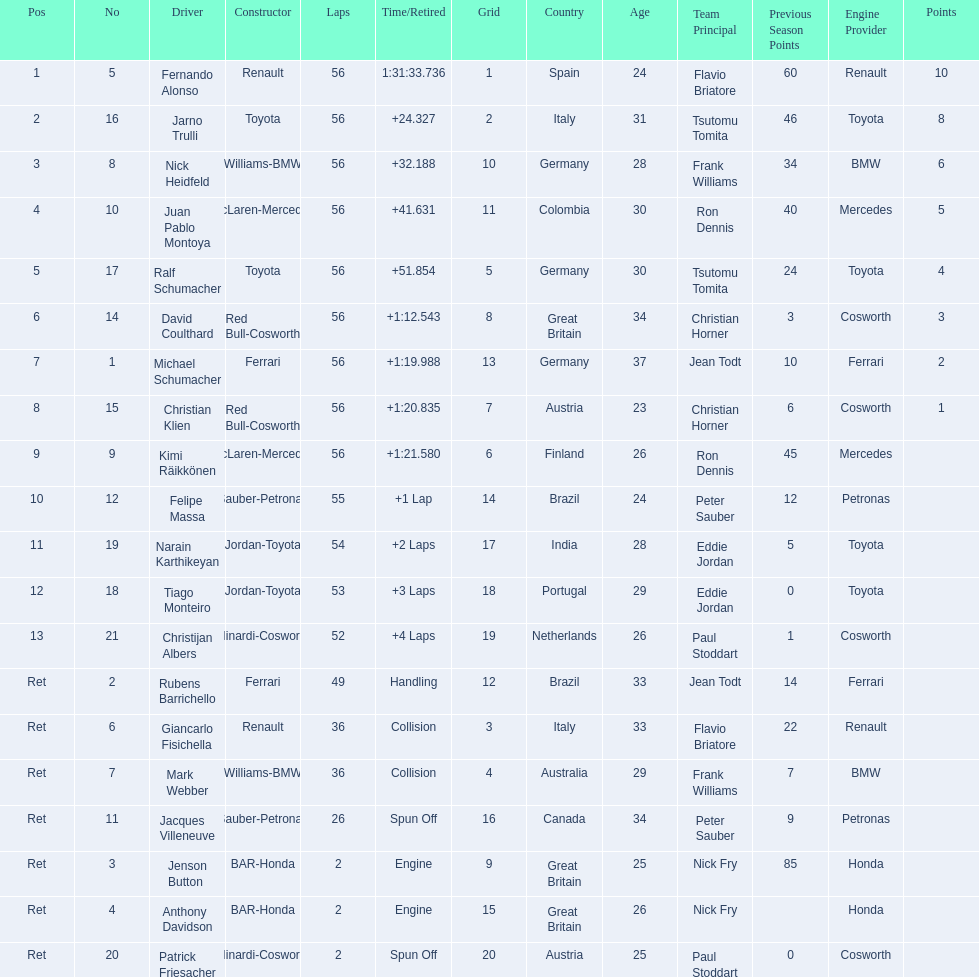What place did fernando alonso finish? 1. How long did it take alonso to finish the race? 1:31:33.736. 